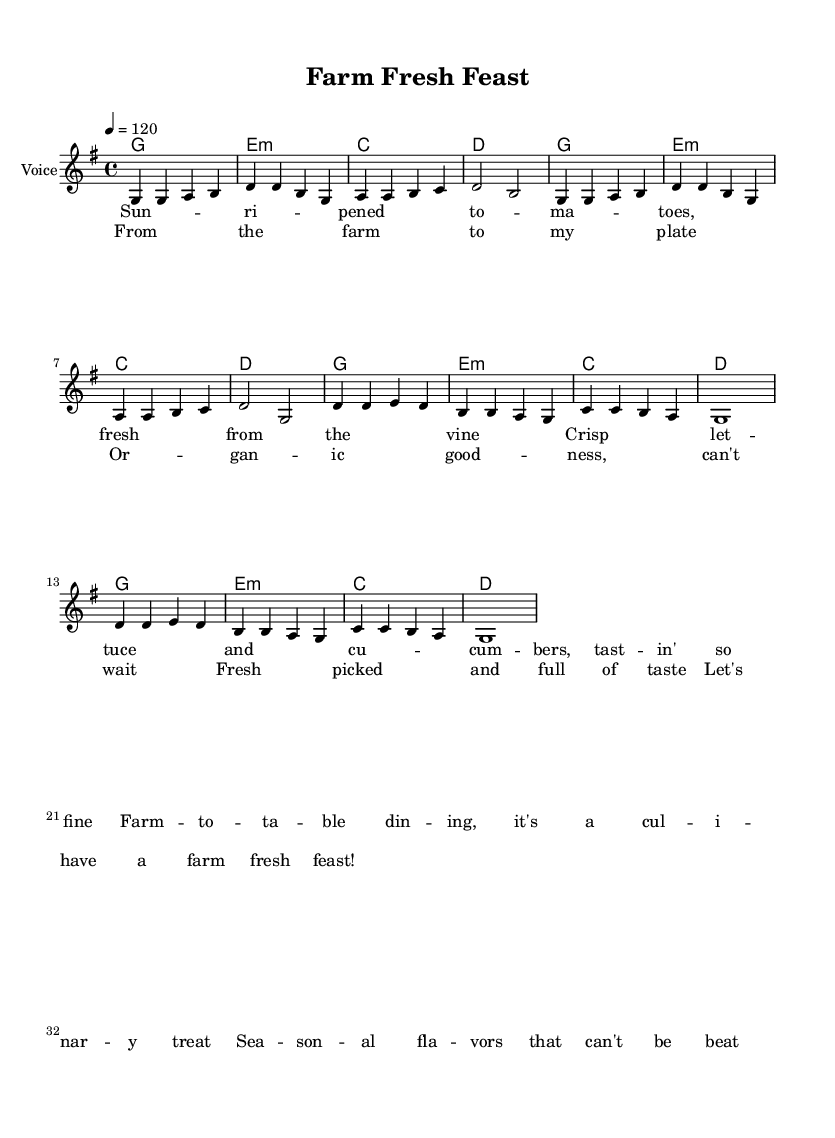What is the key signature of this music? The key signature is G major, which has one sharp (F#).
Answer: G major What is the time signature of this piece? The time signature is 4/4, indicating four beats per measure.
Answer: 4/4 What is the tempo marking of the piece? The tempo marking is 120 beats per minute, indicated as "4 = 120".
Answer: 120 How many measures are in the verse section? The verse section consists of two phrases, each containing four measures, totaling eight measures.
Answer: Eight measures In which section do the lyrics describe seasonal flavors? The lyrics specifically associated with seasonal flavors are found in the verse section.
Answer: Verse How many times does the chorus repeat? The chorus is repeated twice within the structure of the song.
Answer: Twice What type of dining experience does the song emphasize? The song emphasizes a farm-to-table dining experience, highlighting fresh and seasonal ingredients.
Answer: Farm-to-table 